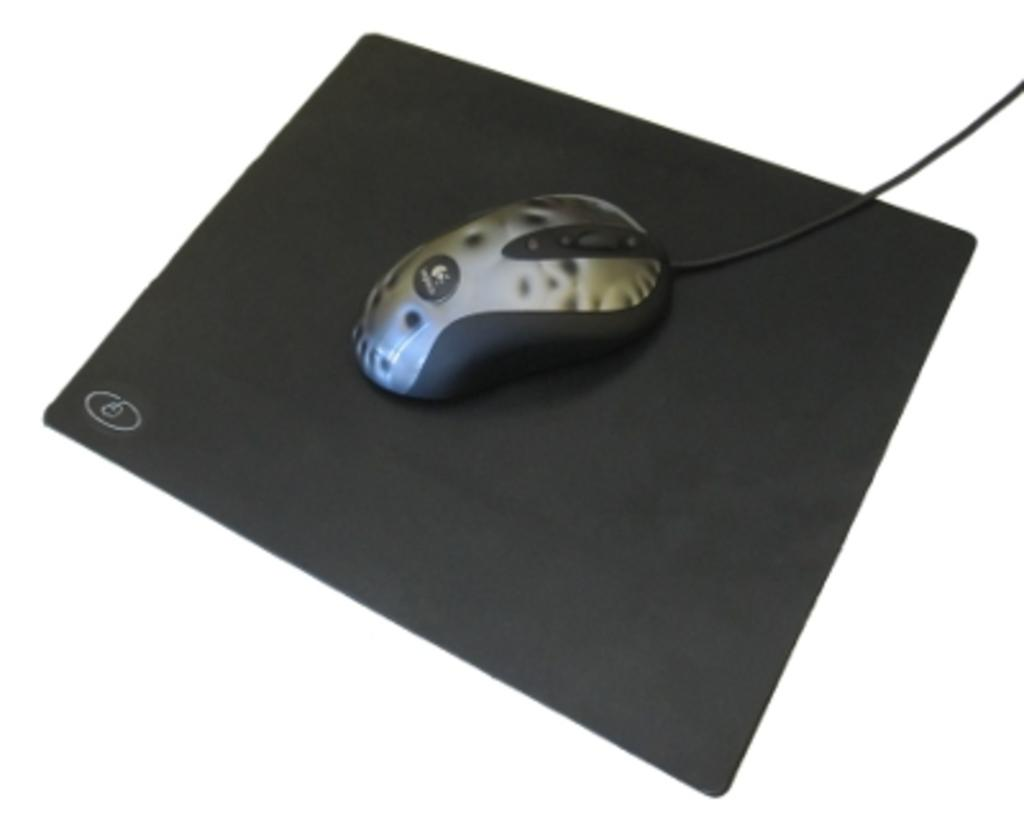What is the main subject of the image? There is a mouse in the image. Where is the mouse located? The mouse is on a mouse pad. What is the color of the mouse pad? The mouse pad is black in color. What color is the background of the image? The background of the image is white. How is the mouse being measured in the image? There is no indication in the image that the mouse is being measured. 